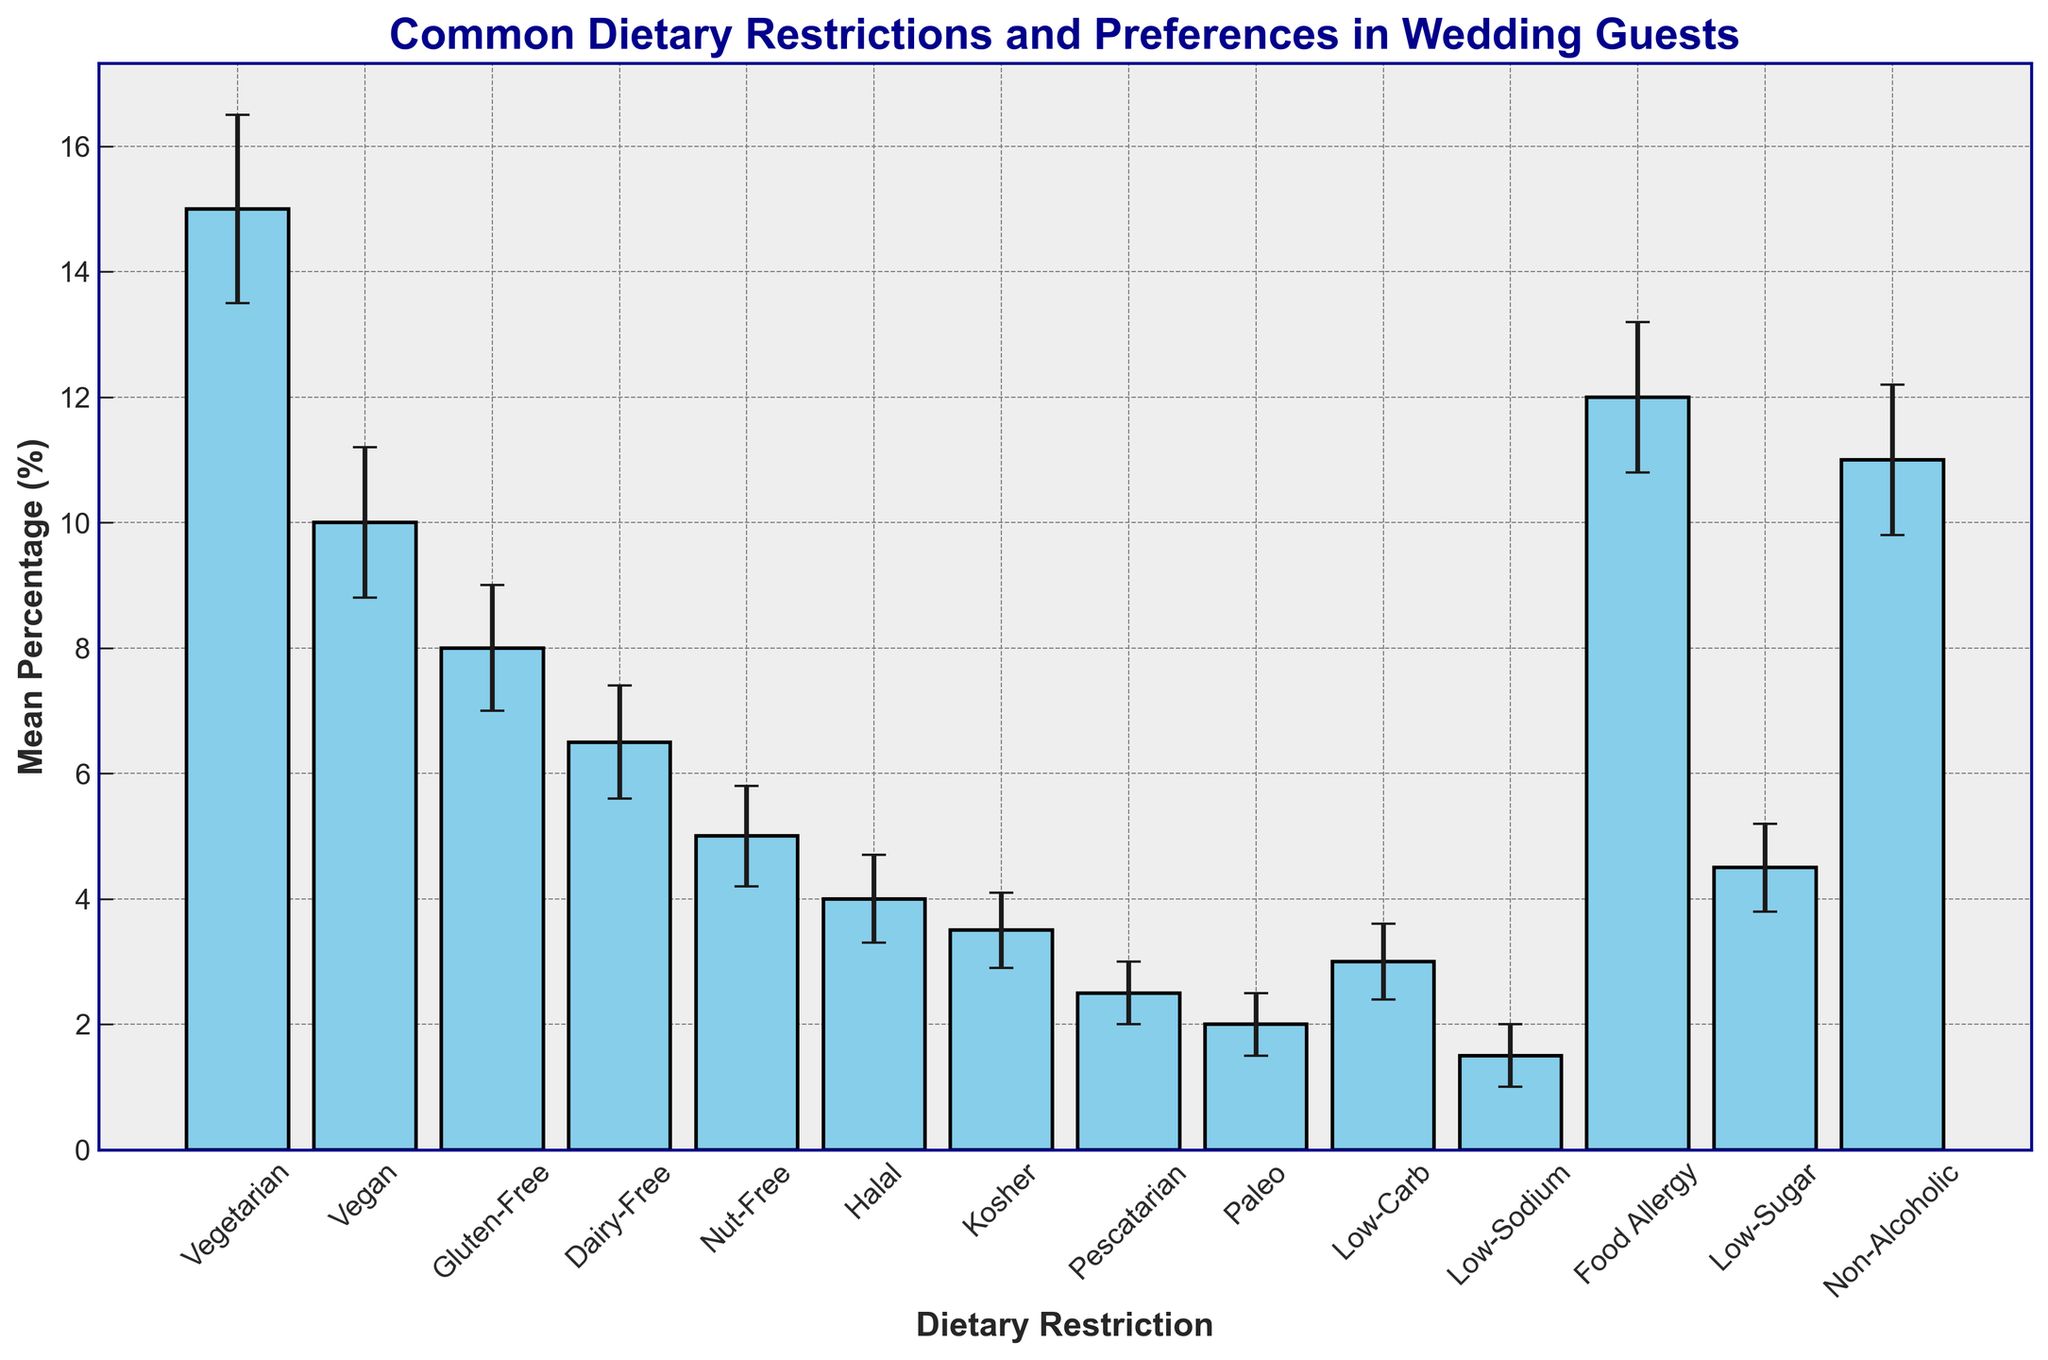Which dietary restriction has the highest mean percentage? The highest bar in the plot represents the dietary restriction with the highest mean percentage.
Answer: Vegetarian Which two dietary restrictions have the closest mean percentages? By examining the bars' heights and their mean percentages, the two closest are Low-Sugar (4.5%) and Halal (4.0%).
Answer: Low-Sugar and Halal What is the difference between the mean percentage of Vegetarian and Vegan? The mean percentage of Vegetarian is 15.0%, and for Vegan, it is 10.0%. The difference is calculated as 15.0% - 10.0%.
Answer: 5.0% Is the mean percentage for Food Allergy more than double that of Nut-Free? The mean percentage for Food Allergy is 12.0%, and for Nut-Free, it is 5.0%. 12.0% is more than double 5.0%.
Answer: Yes Which dietary restriction has the widest confidence interval? The widest confidence interval is found by comparing the range (upper bound minus lower bound) of each restriction. The widest range is for Non-Alcoholic (12.2% - 9.8% = 2.4%).
Answer: Non-Alcoholic What is the average of the mean percentages for Gluten-Free and Dairy-Free? The mean percentage for Gluten-Free is 8.0%, and for Dairy-Free, it is 6.5%. The average is calculated as (8.0% + 6.5%) / 2.
Answer: 7.25% Are there any dietary restrictions with a mean percentage less than 2.0%? By examining the bars, the mean percentage values that are less than 2.0% are only for Low-Sodium.
Answer: Yes (Low-Sodium) Compare the mean percentage of Vegetarian and Non-Alcoholic preferences in terms of their confidence intervals. Which has a larger range? The confidence interval for Vegetarian is from 13.5% to 16.5% (range = 3.0%), and for Non-Alcoholic, it’s from 9.8% to 12.2% (range = 2.4%). Vegetarian has the larger range.
Answer: Vegetarian What is the sum of the lower bounds for the confidence intervals of Dairy-Free and Halal? The lower bound for Dairy-Free is 5.6%, and for Halal, it is 3.3%. The sum is calculated as 5.6% + 3.3%.
Answer: 8.9% How much higher is the mean percentage of Non-Alcoholic preferences compared to the mean percentage of Low-Sugar preferences? The mean percentage of Non-Alcoholic preferences is 11.0%, and that of Low-Sugar preferences is 4.5%. The difference is 11.0% - 4.5%.
Answer: 6.5% 